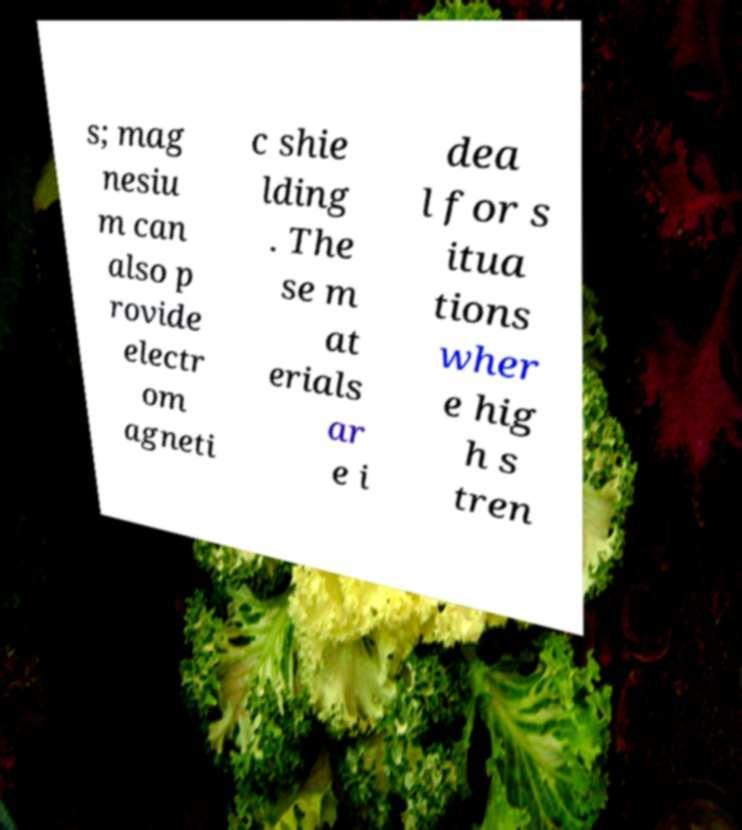Please identify and transcribe the text found in this image. s; mag nesiu m can also p rovide electr om agneti c shie lding . The se m at erials ar e i dea l for s itua tions wher e hig h s tren 